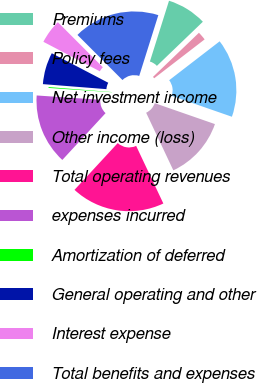Convert chart to OTSL. <chart><loc_0><loc_0><loc_500><loc_500><pie_chart><fcel>Premiums<fcel>Policy fees<fcel>Net investment income<fcel>Other income (loss)<fcel>Total operating revenues<fcel>expenses incurred<fcel>Amortization of deferred<fcel>General operating and other<fcel>Interest expense<fcel>Total benefits and expenses<nl><fcel>7.97%<fcel>1.73%<fcel>15.77%<fcel>12.65%<fcel>18.89%<fcel>14.21%<fcel>0.17%<fcel>6.41%<fcel>4.85%<fcel>17.33%<nl></chart> 